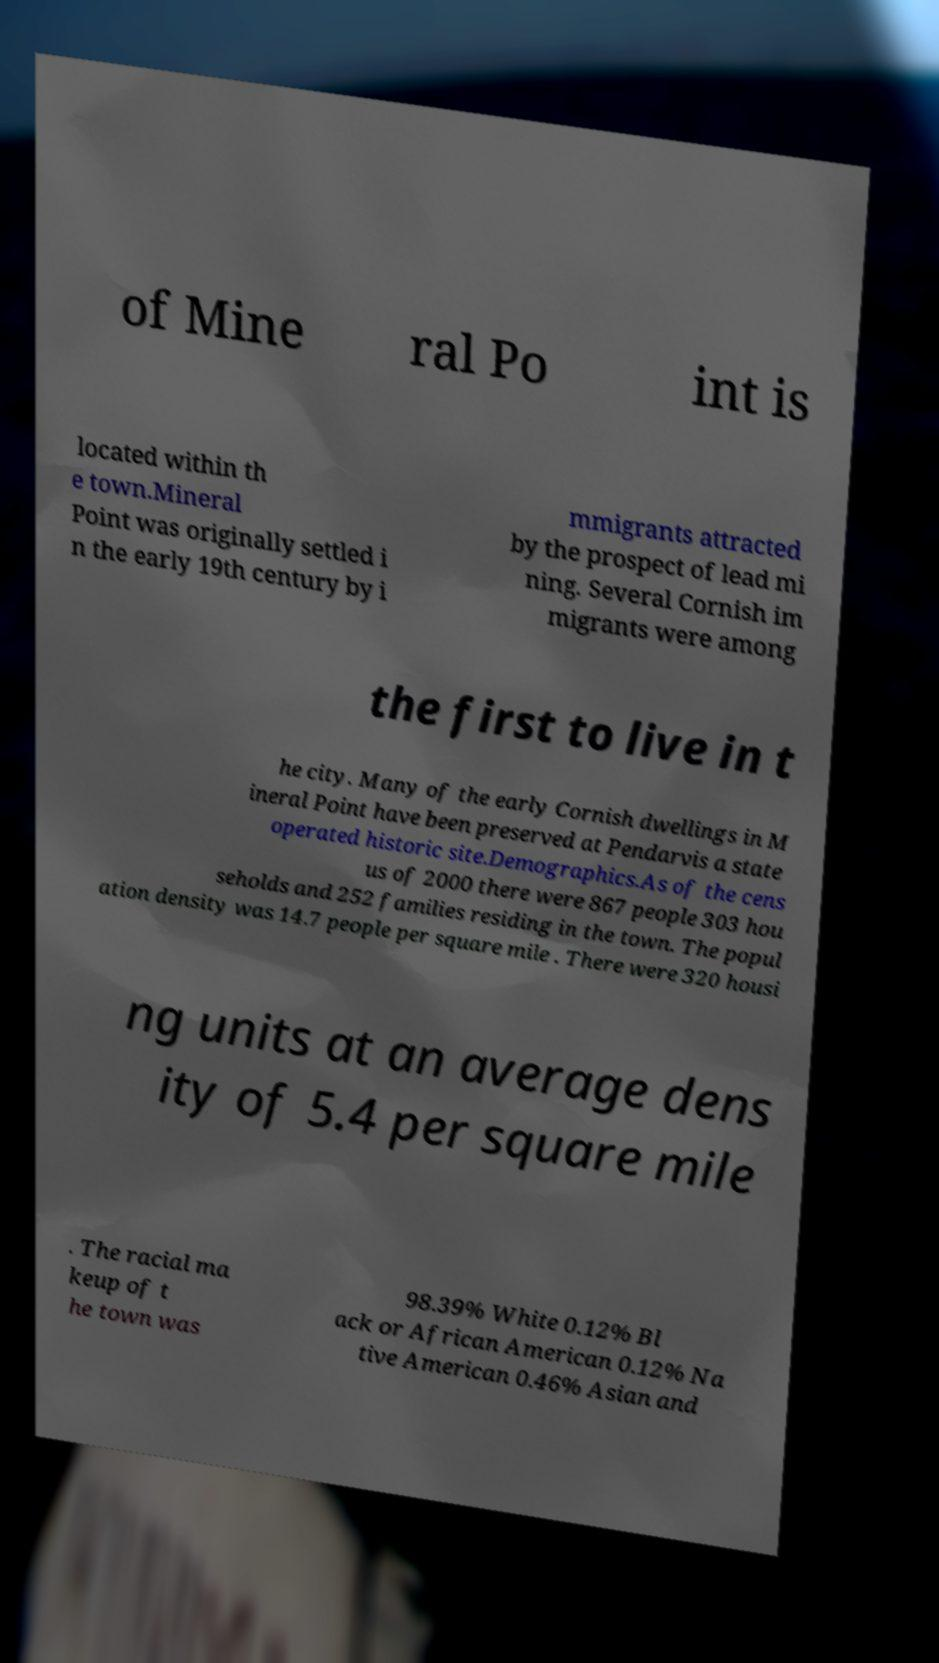For documentation purposes, I need the text within this image transcribed. Could you provide that? of Mine ral Po int is located within th e town.Mineral Point was originally settled i n the early 19th century by i mmigrants attracted by the prospect of lead mi ning. Several Cornish im migrants were among the first to live in t he city. Many of the early Cornish dwellings in M ineral Point have been preserved at Pendarvis a state operated historic site.Demographics.As of the cens us of 2000 there were 867 people 303 hou seholds and 252 families residing in the town. The popul ation density was 14.7 people per square mile . There were 320 housi ng units at an average dens ity of 5.4 per square mile . The racial ma keup of t he town was 98.39% White 0.12% Bl ack or African American 0.12% Na tive American 0.46% Asian and 